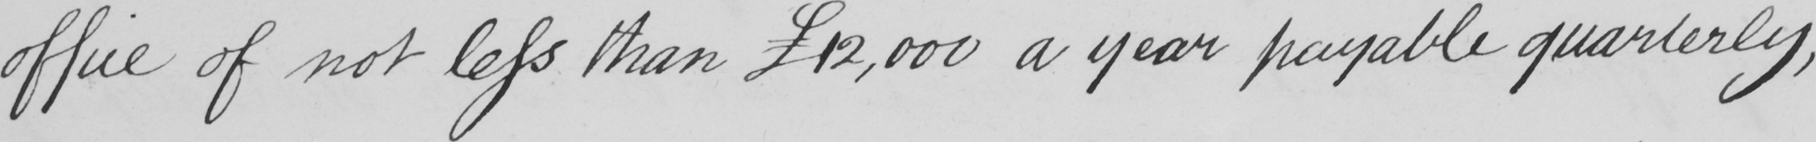Please provide the text content of this handwritten line. office of not less than  £12,000 a year payable quarterly , 